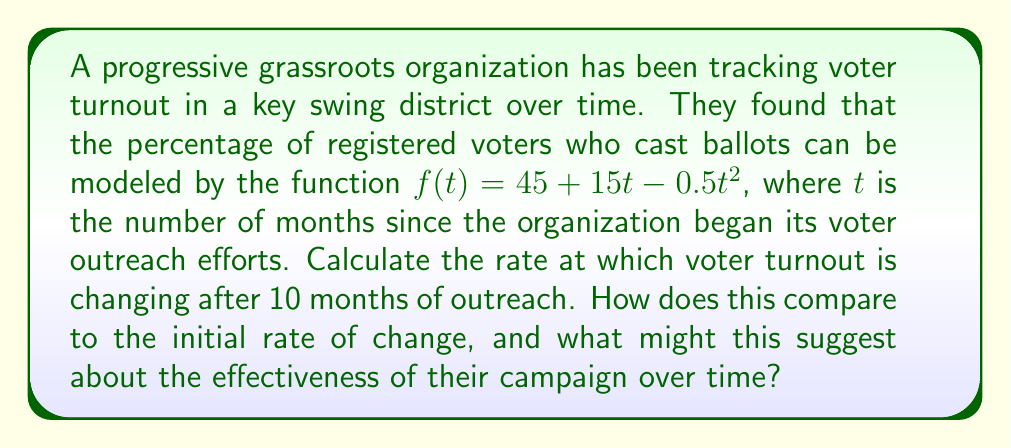Can you answer this question? To solve this problem, we need to use derivatives to find the rate of change in voter turnout.

1. The given function is $f(t) = 45 + 15t - 0.5t^2$

2. To find the rate of change, we need to calculate the derivative of $f(t)$:
   $$f'(t) = 15 - t$$

3. To find the rate of change after 10 months, we evaluate $f'(10)$:
   $$f'(10) = 15 - 10 = 5$$

4. This means that after 10 months, the voter turnout is increasing at a rate of 5% per month.

5. To find the initial rate of change, we evaluate $f'(0)$:
   $$f'(0) = 15 - 0 = 15$$

6. This means that at the start of the campaign, the voter turnout was increasing at a rate of 15% per month.

Comparing these results, we can see that the rate of change has decreased from 15% per month to 5% per month over the 10-month period. This suggests that while the campaign is still effective in increasing voter turnout, its impact is diminishing over time. The organization might need to consider new strategies or intensify their efforts to maintain a higher rate of increase in voter turnout.
Answer: $f'(10) = 5$% per month, decreased from initial $f'(0) = 15$% per month 